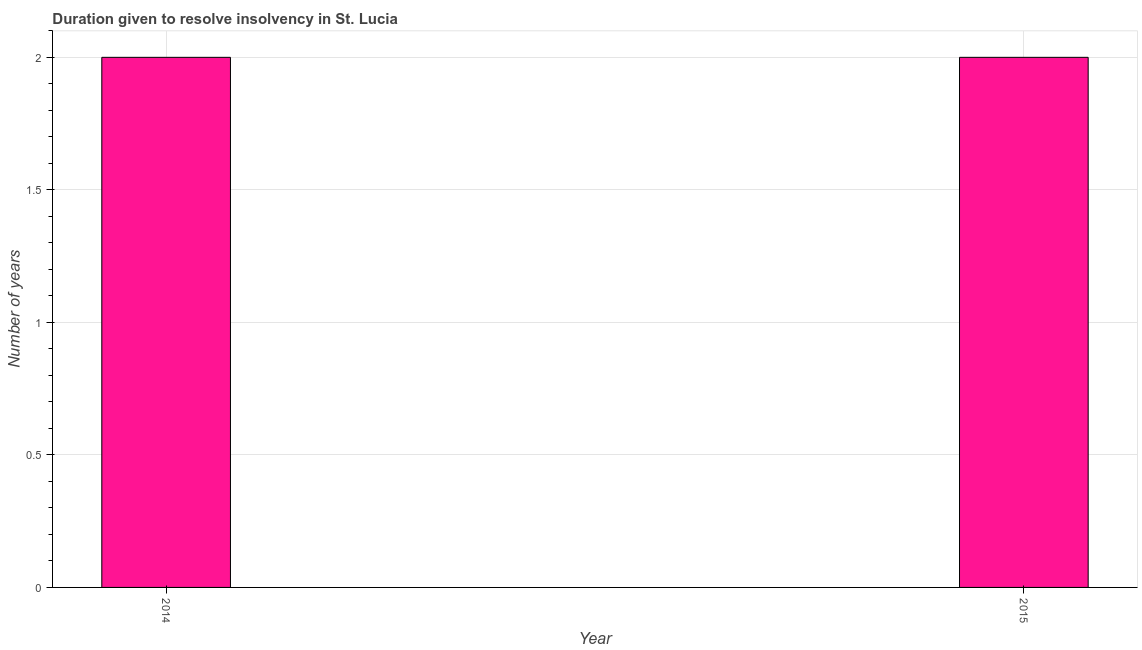Does the graph contain any zero values?
Make the answer very short. No. Does the graph contain grids?
Provide a short and direct response. Yes. What is the title of the graph?
Provide a short and direct response. Duration given to resolve insolvency in St. Lucia. What is the label or title of the X-axis?
Provide a short and direct response. Year. What is the label or title of the Y-axis?
Ensure brevity in your answer.  Number of years. Across all years, what is the minimum number of years to resolve insolvency?
Your answer should be very brief. 2. In which year was the number of years to resolve insolvency maximum?
Provide a succinct answer. 2014. What is the average number of years to resolve insolvency per year?
Offer a very short reply. 2. In how many years, is the number of years to resolve insolvency greater than 1.4 ?
Your response must be concise. 2. Do a majority of the years between 2015 and 2014 (inclusive) have number of years to resolve insolvency greater than 0.6 ?
Provide a short and direct response. No. What is the ratio of the number of years to resolve insolvency in 2014 to that in 2015?
Your response must be concise. 1. Is the number of years to resolve insolvency in 2014 less than that in 2015?
Make the answer very short. No. In how many years, is the number of years to resolve insolvency greater than the average number of years to resolve insolvency taken over all years?
Your response must be concise. 0. How many years are there in the graph?
Your response must be concise. 2. What is the difference between two consecutive major ticks on the Y-axis?
Make the answer very short. 0.5. What is the Number of years in 2015?
Make the answer very short. 2. What is the difference between the Number of years in 2014 and 2015?
Ensure brevity in your answer.  0. 